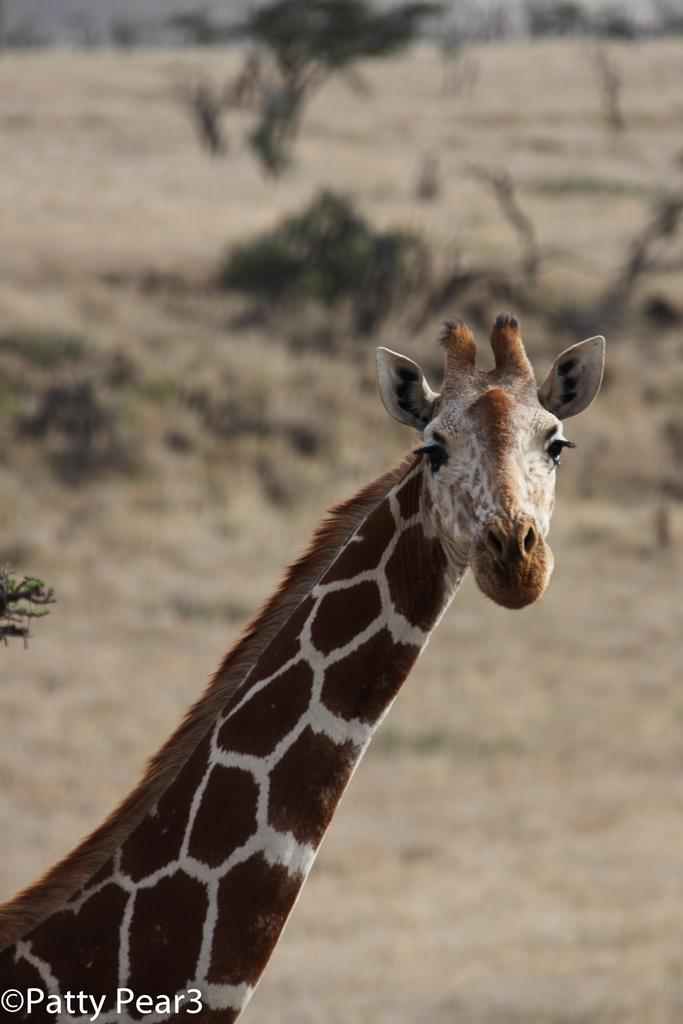What animal is present in the image? There is a giraffe in the image. What type of vegetation can be seen in the image? There are trees visible in the image. What type of nerve is responsible for the giraffe's growth in the image? There is no information about the giraffe's growth or nerves in the image, as it only shows a giraffe and trees. 